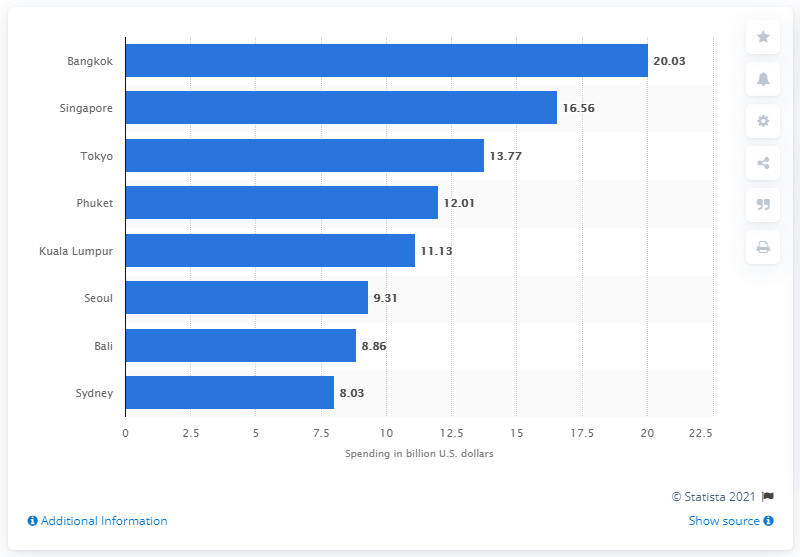Give some essential details in this illustration. In 2018, the estimated international visitor spending in Sydney was 8.03 billion Australian dollars. According to data from 2018, Bangkok was the city that received the highest amount of international visitor spending. In 2018, the amount of international visitor spending in Bangkok reached a total of 20.03 billion U.S. dollars. 